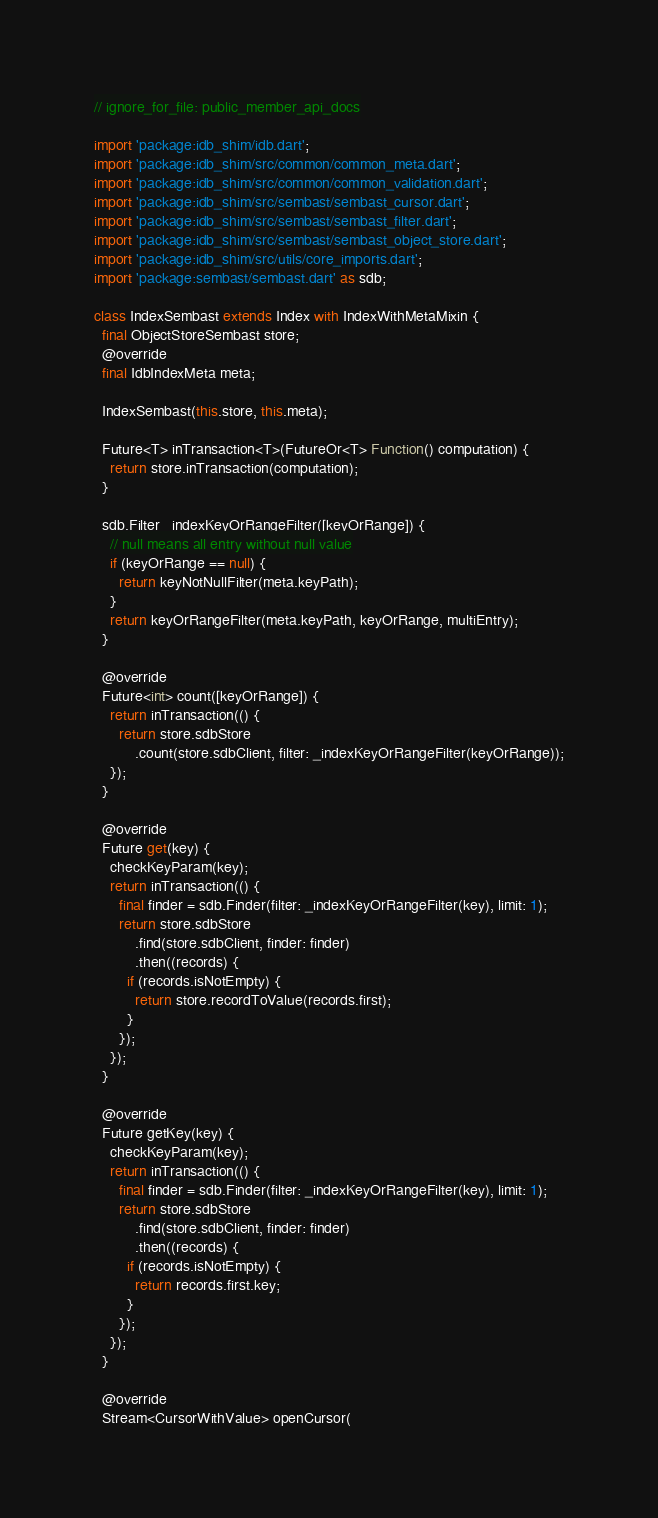Convert code to text. <code><loc_0><loc_0><loc_500><loc_500><_Dart_>// ignore_for_file: public_member_api_docs

import 'package:idb_shim/idb.dart';
import 'package:idb_shim/src/common/common_meta.dart';
import 'package:idb_shim/src/common/common_validation.dart';
import 'package:idb_shim/src/sembast/sembast_cursor.dart';
import 'package:idb_shim/src/sembast/sembast_filter.dart';
import 'package:idb_shim/src/sembast/sembast_object_store.dart';
import 'package:idb_shim/src/utils/core_imports.dart';
import 'package:sembast/sembast.dart' as sdb;

class IndexSembast extends Index with IndexWithMetaMixin {
  final ObjectStoreSembast store;
  @override
  final IdbIndexMeta meta;

  IndexSembast(this.store, this.meta);

  Future<T> inTransaction<T>(FutureOr<T> Function() computation) {
    return store.inTransaction(computation);
  }

  sdb.Filter _indexKeyOrRangeFilter([keyOrRange]) {
    // null means all entry without null value
    if (keyOrRange == null) {
      return keyNotNullFilter(meta.keyPath);
    }
    return keyOrRangeFilter(meta.keyPath, keyOrRange, multiEntry);
  }

  @override
  Future<int> count([keyOrRange]) {
    return inTransaction(() {
      return store.sdbStore
          .count(store.sdbClient, filter: _indexKeyOrRangeFilter(keyOrRange));
    });
  }

  @override
  Future get(key) {
    checkKeyParam(key);
    return inTransaction(() {
      final finder = sdb.Finder(filter: _indexKeyOrRangeFilter(key), limit: 1);
      return store.sdbStore
          .find(store.sdbClient, finder: finder)
          .then((records) {
        if (records.isNotEmpty) {
          return store.recordToValue(records.first);
        }
      });
    });
  }

  @override
  Future getKey(key) {
    checkKeyParam(key);
    return inTransaction(() {
      final finder = sdb.Finder(filter: _indexKeyOrRangeFilter(key), limit: 1);
      return store.sdbStore
          .find(store.sdbClient, finder: finder)
          .then((records) {
        if (records.isNotEmpty) {
          return records.first.key;
        }
      });
    });
  }

  @override
  Stream<CursorWithValue> openCursor(</code> 